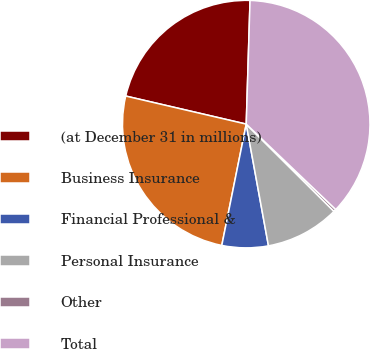<chart> <loc_0><loc_0><loc_500><loc_500><pie_chart><fcel>(at December 31 in millions)<fcel>Business Insurance<fcel>Financial Professional &<fcel>Personal Insurance<fcel>Other<fcel>Total<nl><fcel>21.85%<fcel>25.48%<fcel>6.04%<fcel>9.67%<fcel>0.33%<fcel>36.64%<nl></chart> 